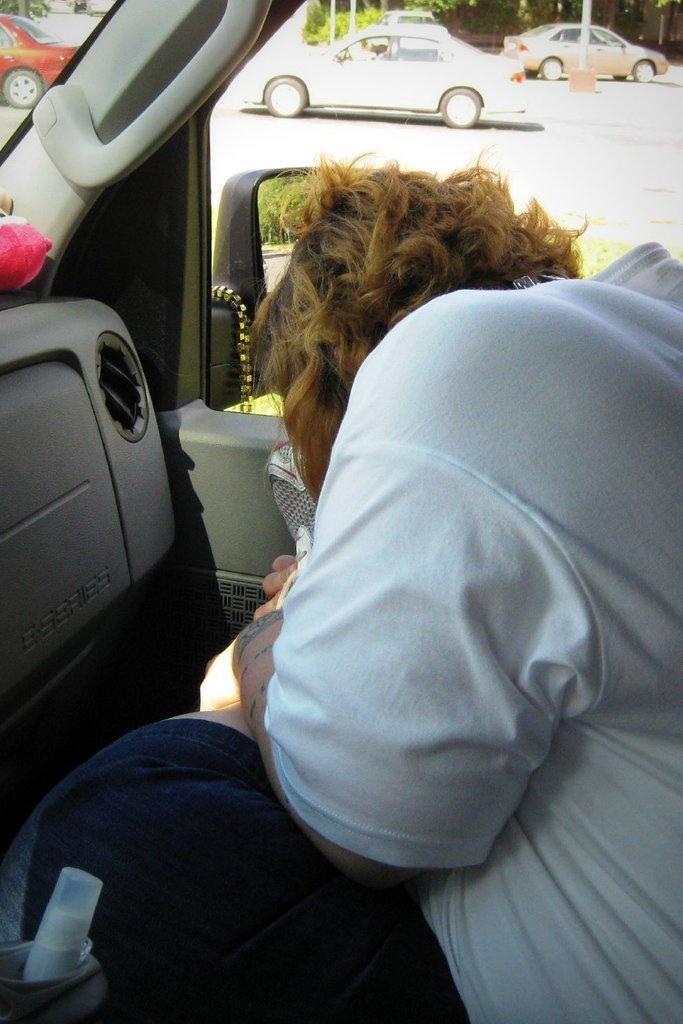How would you summarize this image in a sentence or two? In this image we can see a person inside a vehicle. Through the vehicle we can see other vehicles. Also there are trees and poles. And we can see a bottle at the bottom. 